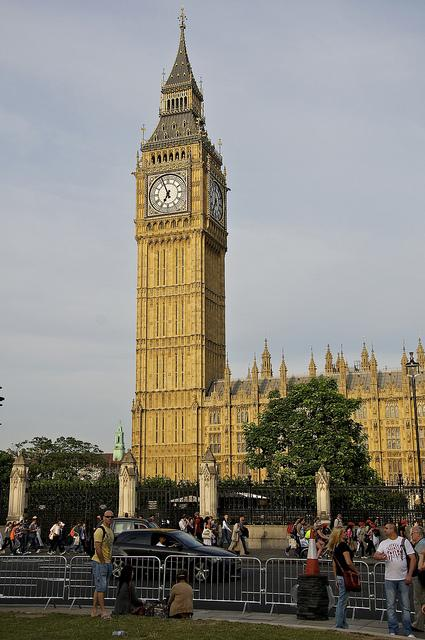The clock is reading five minutes before which hour? seven 